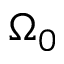<formula> <loc_0><loc_0><loc_500><loc_500>\Omega _ { 0 }</formula> 